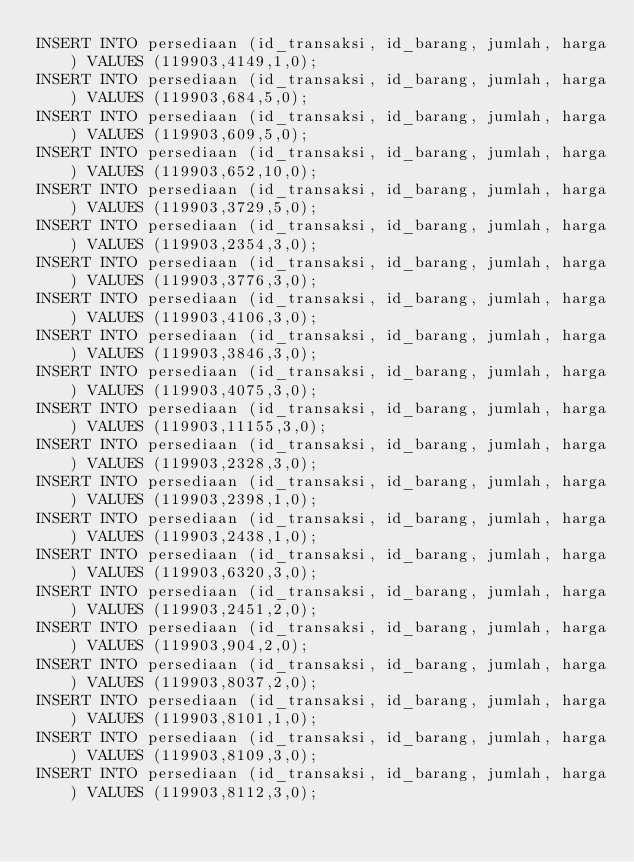Convert code to text. <code><loc_0><loc_0><loc_500><loc_500><_SQL_>INSERT INTO persediaan (id_transaksi, id_barang, jumlah, harga) VALUES (119903,4149,1,0);
INSERT INTO persediaan (id_transaksi, id_barang, jumlah, harga) VALUES (119903,684,5,0);
INSERT INTO persediaan (id_transaksi, id_barang, jumlah, harga) VALUES (119903,609,5,0);
INSERT INTO persediaan (id_transaksi, id_barang, jumlah, harga) VALUES (119903,652,10,0);
INSERT INTO persediaan (id_transaksi, id_barang, jumlah, harga) VALUES (119903,3729,5,0);
INSERT INTO persediaan (id_transaksi, id_barang, jumlah, harga) VALUES (119903,2354,3,0);
INSERT INTO persediaan (id_transaksi, id_barang, jumlah, harga) VALUES (119903,3776,3,0);
INSERT INTO persediaan (id_transaksi, id_barang, jumlah, harga) VALUES (119903,4106,3,0);
INSERT INTO persediaan (id_transaksi, id_barang, jumlah, harga) VALUES (119903,3846,3,0);
INSERT INTO persediaan (id_transaksi, id_barang, jumlah, harga) VALUES (119903,4075,3,0);
INSERT INTO persediaan (id_transaksi, id_barang, jumlah, harga) VALUES (119903,11155,3,0);
INSERT INTO persediaan (id_transaksi, id_barang, jumlah, harga) VALUES (119903,2328,3,0);
INSERT INTO persediaan (id_transaksi, id_barang, jumlah, harga) VALUES (119903,2398,1,0);
INSERT INTO persediaan (id_transaksi, id_barang, jumlah, harga) VALUES (119903,2438,1,0);
INSERT INTO persediaan (id_transaksi, id_barang, jumlah, harga) VALUES (119903,6320,3,0);
INSERT INTO persediaan (id_transaksi, id_barang, jumlah, harga) VALUES (119903,2451,2,0);
INSERT INTO persediaan (id_transaksi, id_barang, jumlah, harga) VALUES (119903,904,2,0);
INSERT INTO persediaan (id_transaksi, id_barang, jumlah, harga) VALUES (119903,8037,2,0);
INSERT INTO persediaan (id_transaksi, id_barang, jumlah, harga) VALUES (119903,8101,1,0);
INSERT INTO persediaan (id_transaksi, id_barang, jumlah, harga) VALUES (119903,8109,3,0);
INSERT INTO persediaan (id_transaksi, id_barang, jumlah, harga) VALUES (119903,8112,3,0);
</code> 